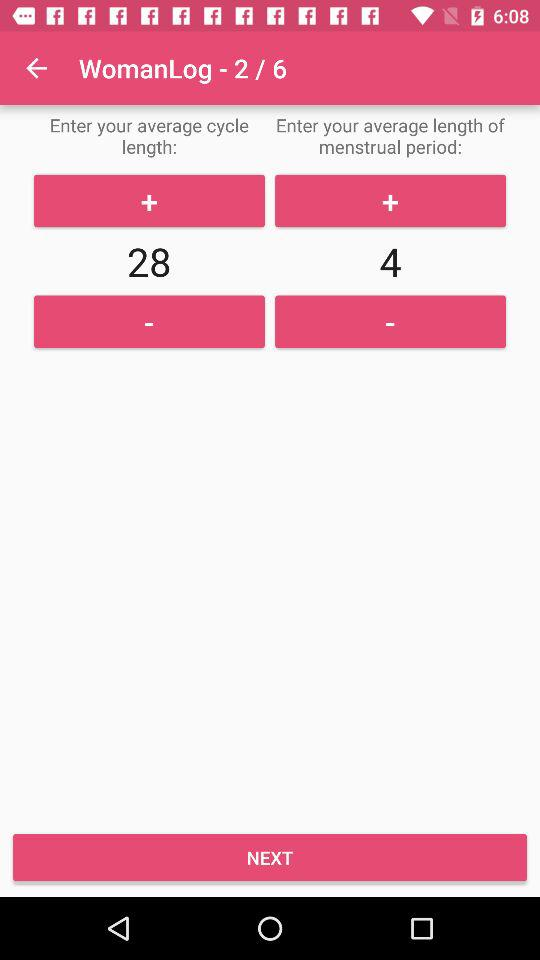What is the average cycle length? The average cycle length is 28. 